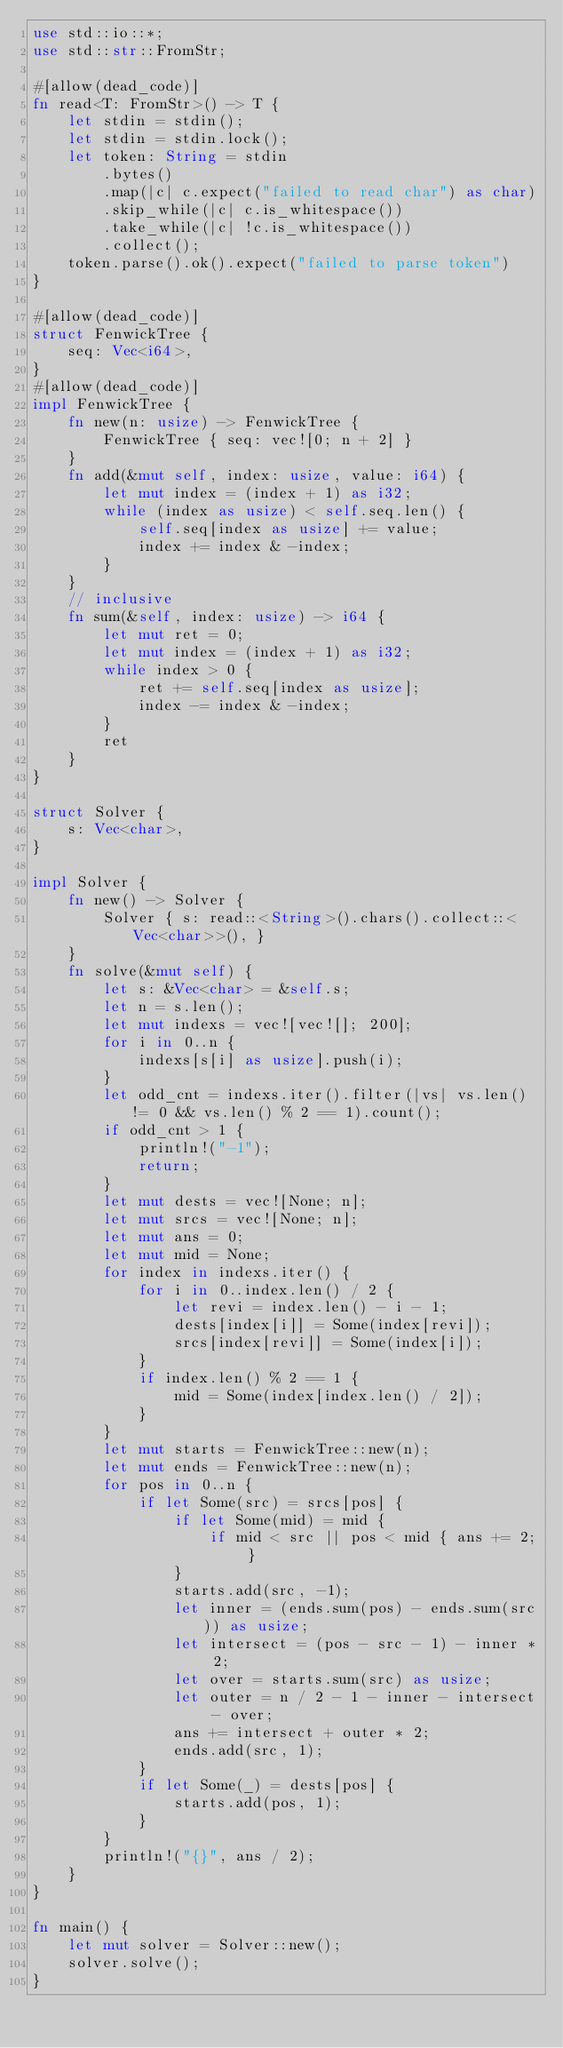<code> <loc_0><loc_0><loc_500><loc_500><_Rust_>use std::io::*;
use std::str::FromStr;

#[allow(dead_code)]
fn read<T: FromStr>() -> T {
    let stdin = stdin();
    let stdin = stdin.lock();
    let token: String = stdin
        .bytes()
        .map(|c| c.expect("failed to read char") as char)
        .skip_while(|c| c.is_whitespace())
        .take_while(|c| !c.is_whitespace())
        .collect();
    token.parse().ok().expect("failed to parse token")
}

#[allow(dead_code)]
struct FenwickTree {
    seq: Vec<i64>,
}
#[allow(dead_code)]
impl FenwickTree {
    fn new(n: usize) -> FenwickTree {
        FenwickTree { seq: vec![0; n + 2] }
    }
    fn add(&mut self, index: usize, value: i64) {
        let mut index = (index + 1) as i32;
        while (index as usize) < self.seq.len() {
            self.seq[index as usize] += value;
            index += index & -index;
        }
    }
    // inclusive
    fn sum(&self, index: usize) -> i64 {
        let mut ret = 0;
        let mut index = (index + 1) as i32;
        while index > 0 {
            ret += self.seq[index as usize];
            index -= index & -index;
        }
        ret
    }
}

struct Solver {
    s: Vec<char>,
}

impl Solver {
    fn new() -> Solver {
        Solver { s: read::<String>().chars().collect::<Vec<char>>(), }
    }
    fn solve(&mut self) {
        let s: &Vec<char> = &self.s;
        let n = s.len();
        let mut indexs = vec![vec![]; 200];
        for i in 0..n {
            indexs[s[i] as usize].push(i);
        }
        let odd_cnt = indexs.iter().filter(|vs| vs.len() != 0 && vs.len() % 2 == 1).count();
        if odd_cnt > 1 {
            println!("-1");
            return;
        }
        let mut dests = vec![None; n];
        let mut srcs = vec![None; n];
        let mut ans = 0;
        let mut mid = None;
        for index in indexs.iter() {
            for i in 0..index.len() / 2 {
                let revi = index.len() - i - 1;
                dests[index[i]] = Some(index[revi]);
                srcs[index[revi]] = Some(index[i]);
            }
            if index.len() % 2 == 1 {
                mid = Some(index[index.len() / 2]);
            }
        }   
        let mut starts = FenwickTree::new(n);
        let mut ends = FenwickTree::new(n);
        for pos in 0..n {
            if let Some(src) = srcs[pos] {
                if let Some(mid) = mid {
                    if mid < src || pos < mid { ans += 2; }
                }
                starts.add(src, -1);
                let inner = (ends.sum(pos) - ends.sum(src)) as usize;
                let intersect = (pos - src - 1) - inner * 2;
                let over = starts.sum(src) as usize;
                let outer = n / 2 - 1 - inner - intersect - over;
                ans += intersect + outer * 2;
                ends.add(src, 1);
            }
            if let Some(_) = dests[pos] {
                starts.add(pos, 1);
            }
        }
        println!("{}", ans / 2);
    }
}

fn main() {
    let mut solver = Solver::new();
    solver.solve();
}</code> 